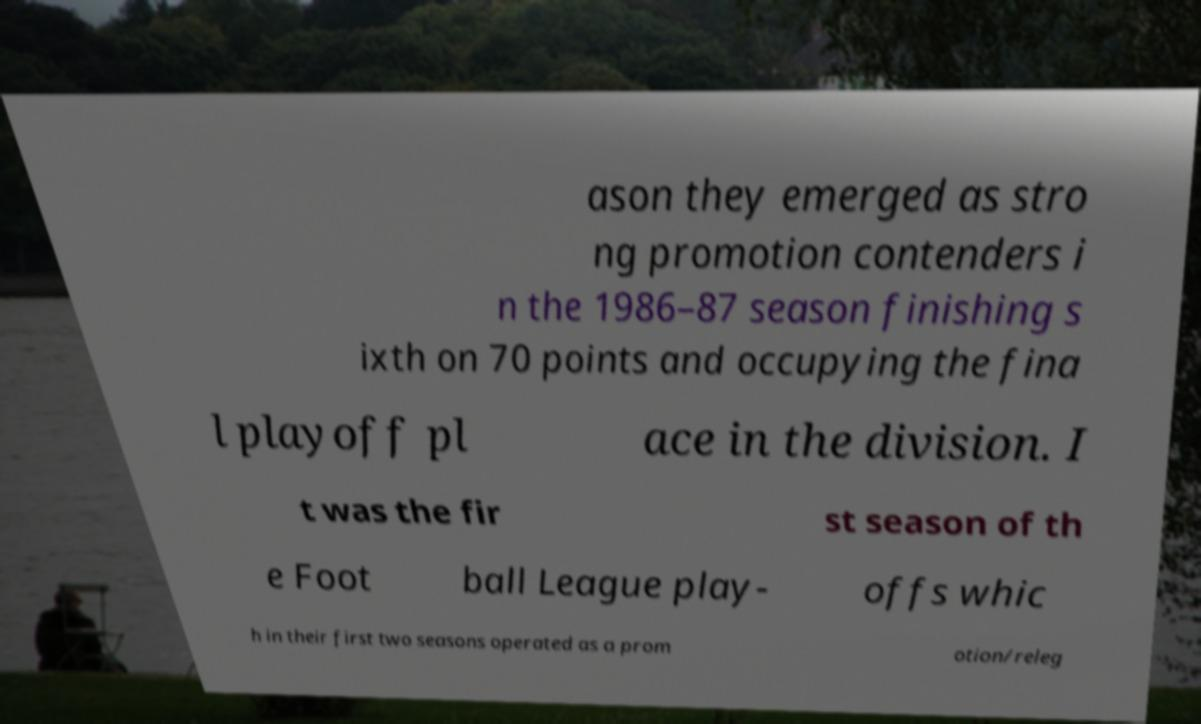Please read and relay the text visible in this image. What does it say? ason they emerged as stro ng promotion contenders i n the 1986–87 season finishing s ixth on 70 points and occupying the fina l playoff pl ace in the division. I t was the fir st season of th e Foot ball League play- offs whic h in their first two seasons operated as a prom otion/releg 